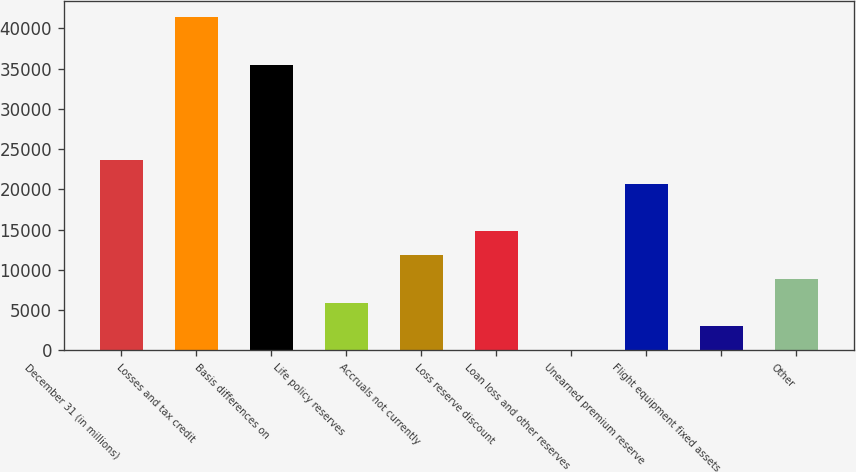<chart> <loc_0><loc_0><loc_500><loc_500><bar_chart><fcel>December 31 (in millions)<fcel>Losses and tax credit<fcel>Basis differences on<fcel>Life policy reserves<fcel>Accruals not currently<fcel>Loss reserve discount<fcel>Loan loss and other reserves<fcel>Unearned premium reserve<fcel>Flight equipment fixed assets<fcel>Other<nl><fcel>23638.4<fcel>41361.2<fcel>35453.6<fcel>5915.6<fcel>11823.2<fcel>14777<fcel>8<fcel>20684.6<fcel>2961.8<fcel>8869.4<nl></chart> 